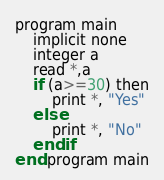<code> <loc_0><loc_0><loc_500><loc_500><_Nim_>program main
	implicit none
    integer a
    read *,a
    if (a>=30) then
    	print *, "Yes"
    else
    	print *, "No"
    end if
end program main</code> 